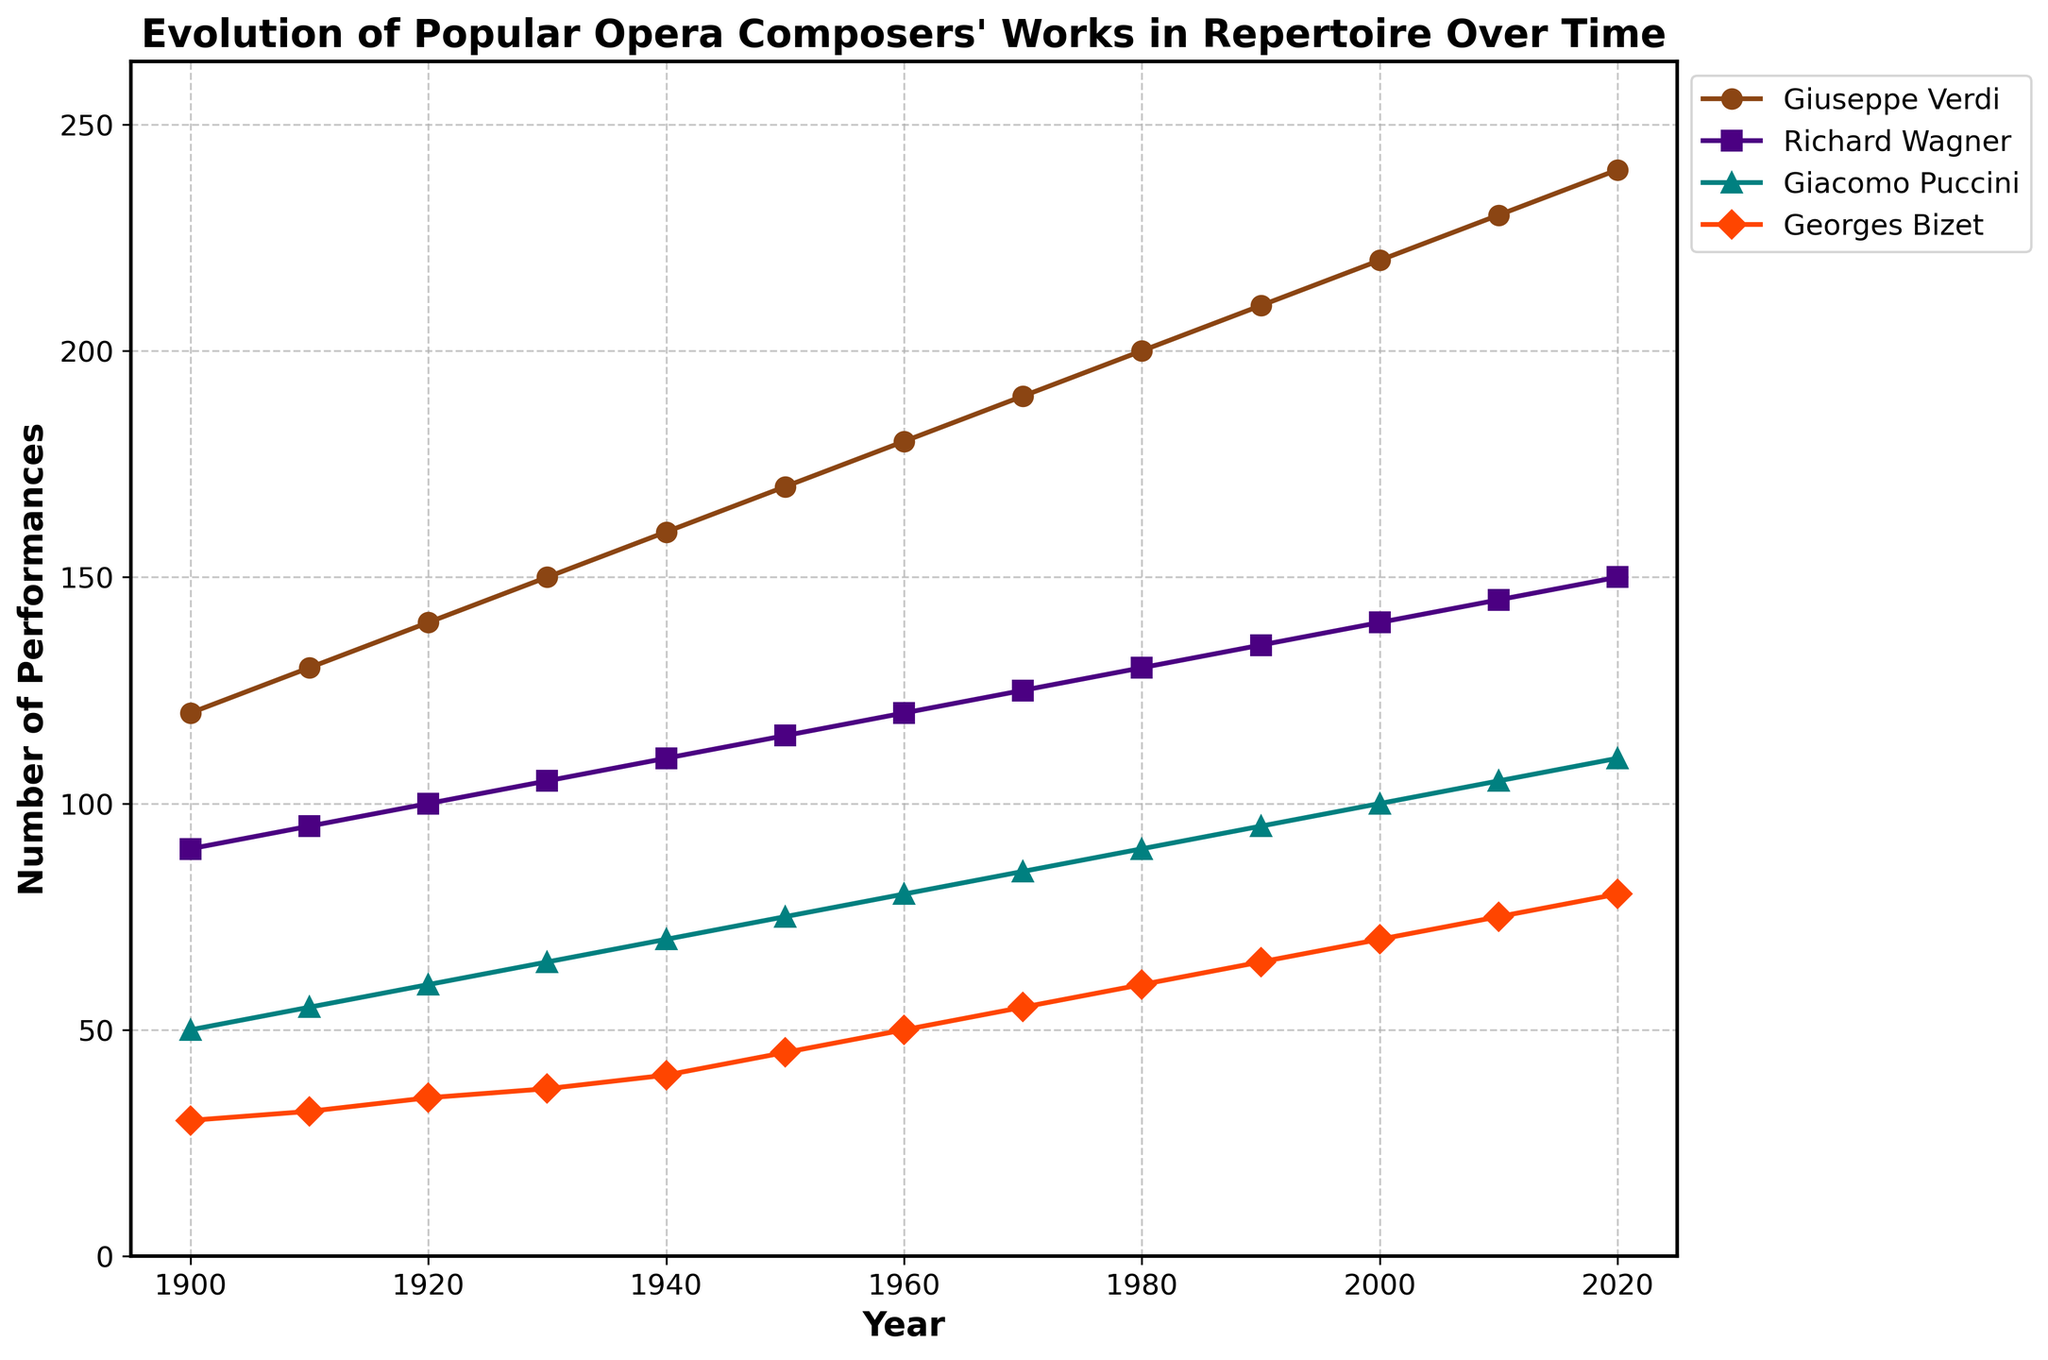What is the title of the plot? The title of the plot is located at the top and reads "Evolution of Popular Opera Composers' Works in Repertoire Over Time".
Answer: Evolution of Popular Opera Composers' Works in Repertoire Over Time Which composer had the highest number of performances in 1950? In 1950, the plot shows the highest point corresponding to Giuseppe Verdi, with the other composers having lower performance counts.
Answer: Giuseppe Verdi How many compositional lines are presented in the figure? The plot contains lines for four composers: Giuseppe Verdi, Richard Wagner, Giacomo Puccini, and Georges Bizet.
Answer: Four What is the trend of Giacomo Puccini's performances from 1900 to 2020? To identify the trend, observe the position of Giacomo Puccini's line from 1900 to 2020. It consistently increases over time.
Answer: Increasing By how much did Georges Bizet's performances increase from 1940 to 1960? In 1940, Georges Bizet had 40 performances, and in 1960, he had 50 performances. The increase is calculated as 50 - 40.
Answer: 10 Compare the number of performances of Richard Wagner in 1900 and 2020. In 1900, Richard Wagner had 90 performances and in 2020, he had 150 performances. Comparatively, the performances increased from 90 to 150.
Answer: Increased Which composer shows the most significant relative increase in performances from the year 2000 to 2010? By comparing the slopes of the lines from 2000 to 2010, Giacomo Puccini appears to have the steepest increase.
Answer: Giacomo Puccini What is the average number of performances for Georges Bizet between 1900 and 2020? Sum of Georges Bizet's performances from 1900 to 2020 (30+32+35+37+40+45+50+55+60+65+70+75+80) = 674. Divide by the number of years (13). 674 / 13 ≈ 51.85.
Answer: Approximately 51.85 Which composer had the least variation in the number of performances over the time period? Observing the plot's lines, Georges Bizet's line is the flattest, indicating the least variation in performances over time.
Answer: Georges Bizet What is the overall increase in the number of performances for Giuseppe Verdi from 1900 to 2020? Giuseppe Verdi's performances in 1900 were 120, and in 2020 they were 240. The increase is calculated as 240 - 120.
Answer: 120 